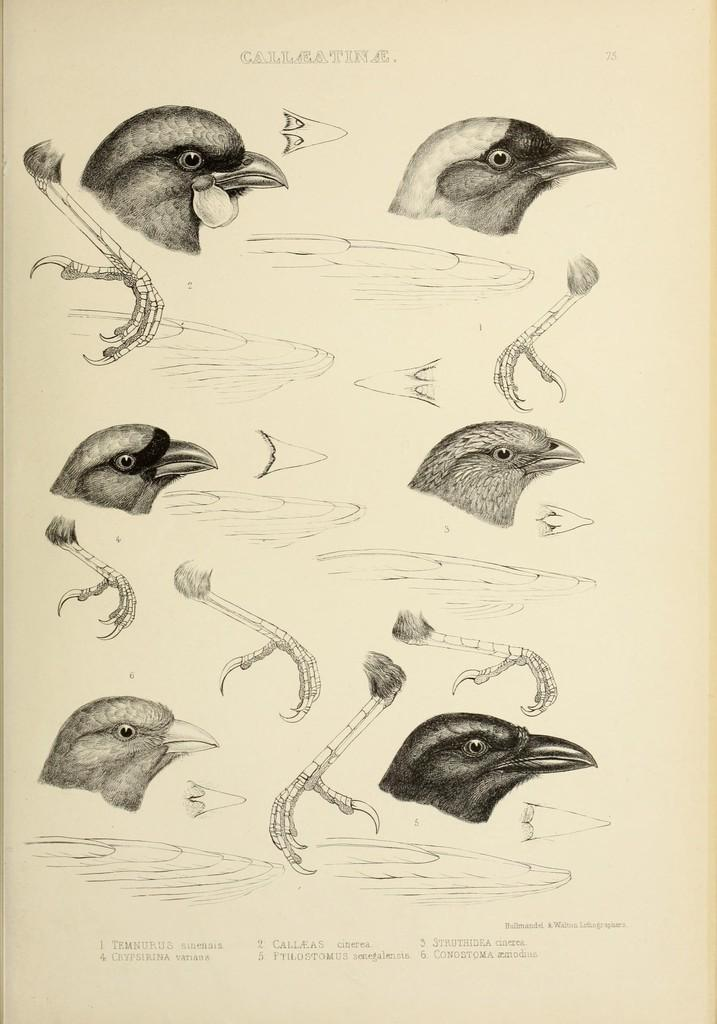What type of animals can be seen in the image? There are birds in the image. What parts of the birds are visible? The birds' faces, legs, and wings are visible in the image. Is there any text present in the image? Yes, there is some text in the image. What type of mint is growing on the top of the birds' heads in the image? There is no mint or any plant growth visible on the birds' heads in the image. What kind of agreement is being signed by the birds in the image? There is no agreement or any indication of a signing event in the image; it simply features birds with visible faces, legs, and wings. 